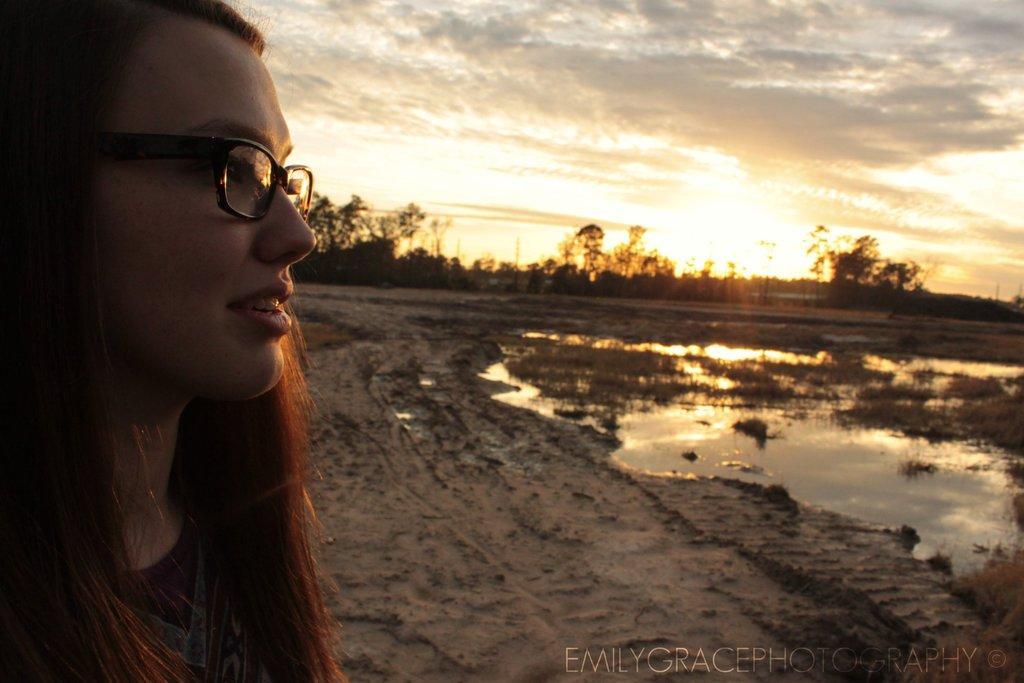Please provide a concise description of this image. On the left there is a woman. In the background we can see sand,water,poles,trees and clouds in the sky. 